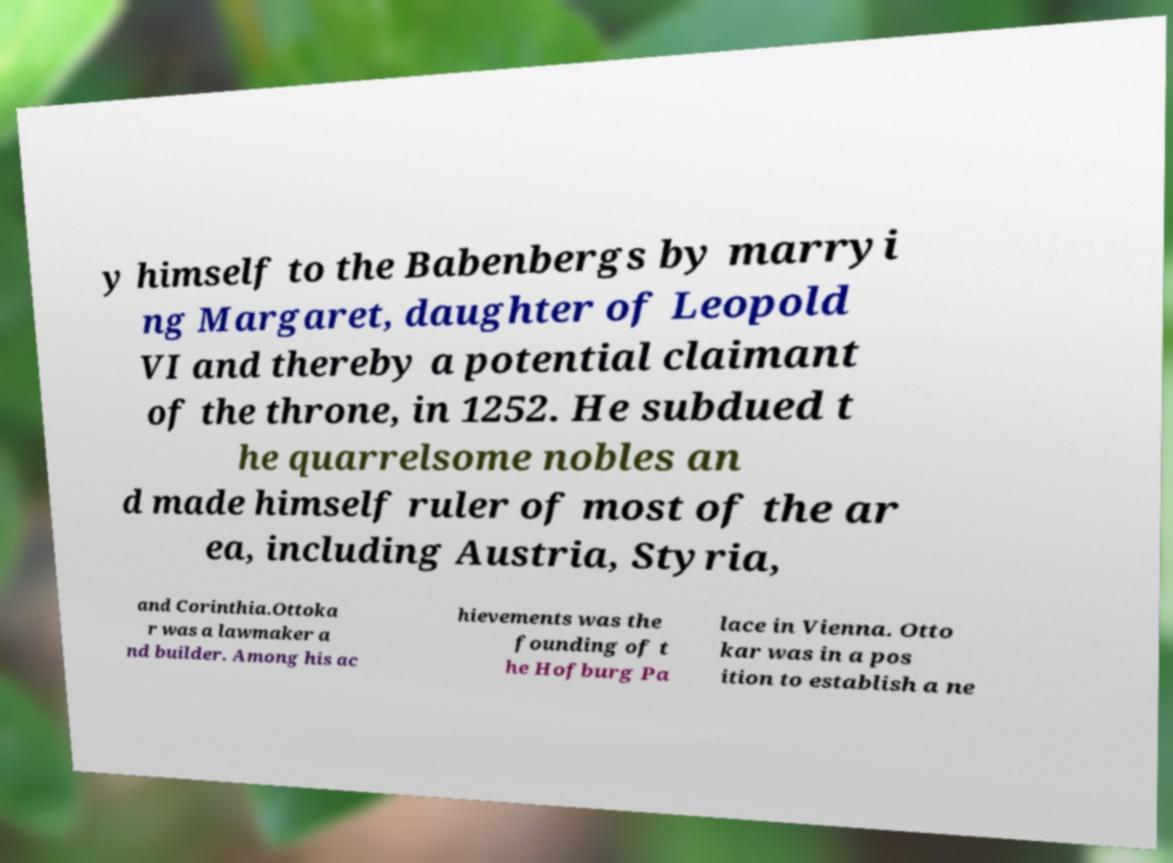Please identify and transcribe the text found in this image. y himself to the Babenbergs by marryi ng Margaret, daughter of Leopold VI and thereby a potential claimant of the throne, in 1252. He subdued t he quarrelsome nobles an d made himself ruler of most of the ar ea, including Austria, Styria, and Corinthia.Ottoka r was a lawmaker a nd builder. Among his ac hievements was the founding of t he Hofburg Pa lace in Vienna. Otto kar was in a pos ition to establish a ne 